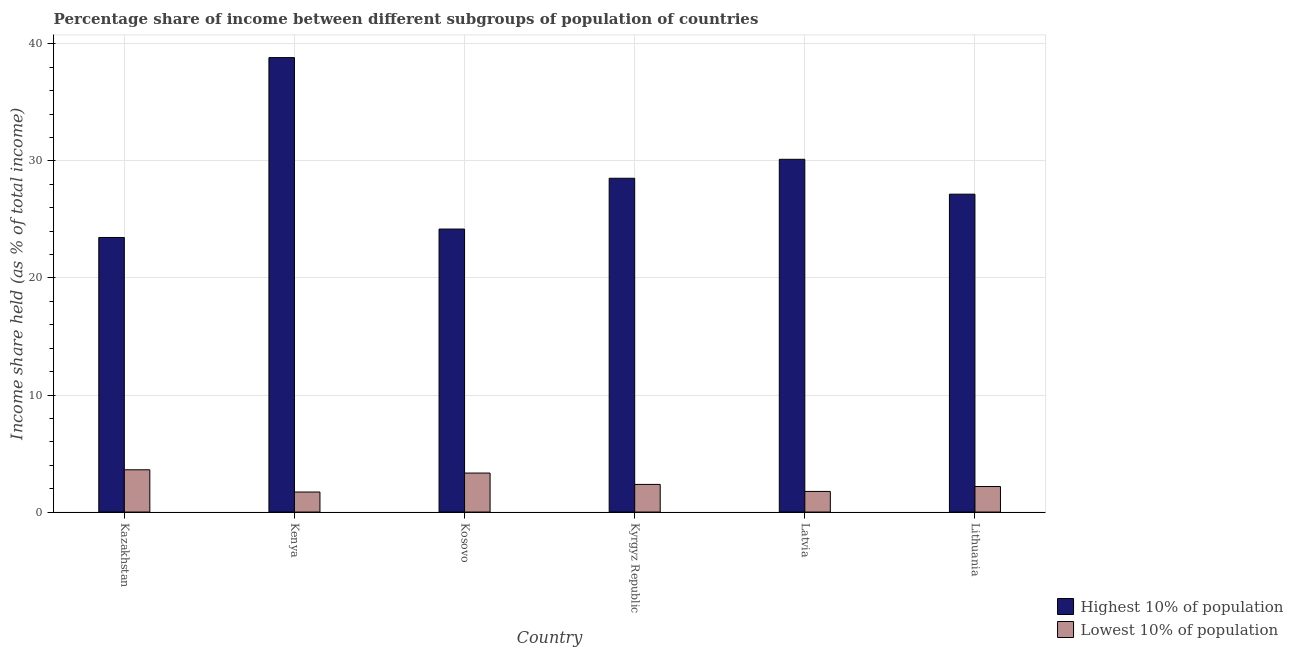How many groups of bars are there?
Provide a succinct answer. 6. Are the number of bars on each tick of the X-axis equal?
Offer a very short reply. Yes. How many bars are there on the 1st tick from the left?
Your answer should be compact. 2. What is the label of the 3rd group of bars from the left?
Provide a short and direct response. Kosovo. In how many cases, is the number of bars for a given country not equal to the number of legend labels?
Ensure brevity in your answer.  0. What is the income share held by lowest 10% of the population in Latvia?
Make the answer very short. 1.76. Across all countries, what is the maximum income share held by highest 10% of the population?
Provide a succinct answer. 38.83. Across all countries, what is the minimum income share held by lowest 10% of the population?
Offer a terse response. 1.71. In which country was the income share held by highest 10% of the population maximum?
Provide a short and direct response. Kenya. In which country was the income share held by highest 10% of the population minimum?
Your answer should be compact. Kazakhstan. What is the total income share held by highest 10% of the population in the graph?
Make the answer very short. 172.29. What is the difference between the income share held by highest 10% of the population in Kenya and that in Lithuania?
Make the answer very short. 11.67. What is the difference between the income share held by lowest 10% of the population in Kazakhstan and the income share held by highest 10% of the population in Latvia?
Your response must be concise. -26.53. What is the average income share held by lowest 10% of the population per country?
Ensure brevity in your answer.  2.49. What is the difference between the income share held by lowest 10% of the population and income share held by highest 10% of the population in Lithuania?
Keep it short and to the point. -24.98. In how many countries, is the income share held by highest 10% of the population greater than 16 %?
Make the answer very short. 6. What is the ratio of the income share held by lowest 10% of the population in Kenya to that in Latvia?
Your answer should be compact. 0.97. Is the income share held by lowest 10% of the population in Kenya less than that in Kosovo?
Give a very brief answer. Yes. Is the difference between the income share held by lowest 10% of the population in Kazakhstan and Kyrgyz Republic greater than the difference between the income share held by highest 10% of the population in Kazakhstan and Kyrgyz Republic?
Make the answer very short. Yes. What is the difference between the highest and the second highest income share held by lowest 10% of the population?
Your answer should be compact. 0.28. What is the difference between the highest and the lowest income share held by highest 10% of the population?
Provide a succinct answer. 15.37. What does the 2nd bar from the left in Kosovo represents?
Make the answer very short. Lowest 10% of population. What does the 1st bar from the right in Kosovo represents?
Keep it short and to the point. Lowest 10% of population. What is the difference between two consecutive major ticks on the Y-axis?
Your answer should be very brief. 10. Are the values on the major ticks of Y-axis written in scientific E-notation?
Your response must be concise. No. What is the title of the graph?
Give a very brief answer. Percentage share of income between different subgroups of population of countries. Does "Depositors" appear as one of the legend labels in the graph?
Your answer should be very brief. No. What is the label or title of the Y-axis?
Ensure brevity in your answer.  Income share held (as % of total income). What is the Income share held (as % of total income) in Highest 10% of population in Kazakhstan?
Ensure brevity in your answer.  23.46. What is the Income share held (as % of total income) of Lowest 10% of population in Kazakhstan?
Make the answer very short. 3.61. What is the Income share held (as % of total income) in Highest 10% of population in Kenya?
Your answer should be compact. 38.83. What is the Income share held (as % of total income) of Lowest 10% of population in Kenya?
Your answer should be compact. 1.71. What is the Income share held (as % of total income) in Highest 10% of population in Kosovo?
Your answer should be compact. 24.18. What is the Income share held (as % of total income) of Lowest 10% of population in Kosovo?
Your answer should be very brief. 3.33. What is the Income share held (as % of total income) of Highest 10% of population in Kyrgyz Republic?
Offer a very short reply. 28.52. What is the Income share held (as % of total income) in Lowest 10% of population in Kyrgyz Republic?
Keep it short and to the point. 2.36. What is the Income share held (as % of total income) in Highest 10% of population in Latvia?
Make the answer very short. 30.14. What is the Income share held (as % of total income) of Lowest 10% of population in Latvia?
Ensure brevity in your answer.  1.76. What is the Income share held (as % of total income) of Highest 10% of population in Lithuania?
Your response must be concise. 27.16. What is the Income share held (as % of total income) in Lowest 10% of population in Lithuania?
Offer a terse response. 2.18. Across all countries, what is the maximum Income share held (as % of total income) in Highest 10% of population?
Your answer should be very brief. 38.83. Across all countries, what is the maximum Income share held (as % of total income) of Lowest 10% of population?
Your answer should be compact. 3.61. Across all countries, what is the minimum Income share held (as % of total income) of Highest 10% of population?
Offer a terse response. 23.46. Across all countries, what is the minimum Income share held (as % of total income) of Lowest 10% of population?
Offer a terse response. 1.71. What is the total Income share held (as % of total income) in Highest 10% of population in the graph?
Keep it short and to the point. 172.29. What is the total Income share held (as % of total income) of Lowest 10% of population in the graph?
Offer a very short reply. 14.95. What is the difference between the Income share held (as % of total income) in Highest 10% of population in Kazakhstan and that in Kenya?
Keep it short and to the point. -15.37. What is the difference between the Income share held (as % of total income) in Highest 10% of population in Kazakhstan and that in Kosovo?
Your answer should be compact. -0.72. What is the difference between the Income share held (as % of total income) of Lowest 10% of population in Kazakhstan and that in Kosovo?
Give a very brief answer. 0.28. What is the difference between the Income share held (as % of total income) of Highest 10% of population in Kazakhstan and that in Kyrgyz Republic?
Give a very brief answer. -5.06. What is the difference between the Income share held (as % of total income) in Highest 10% of population in Kazakhstan and that in Latvia?
Give a very brief answer. -6.68. What is the difference between the Income share held (as % of total income) of Lowest 10% of population in Kazakhstan and that in Latvia?
Give a very brief answer. 1.85. What is the difference between the Income share held (as % of total income) in Highest 10% of population in Kazakhstan and that in Lithuania?
Your answer should be very brief. -3.7. What is the difference between the Income share held (as % of total income) of Lowest 10% of population in Kazakhstan and that in Lithuania?
Offer a very short reply. 1.43. What is the difference between the Income share held (as % of total income) in Highest 10% of population in Kenya and that in Kosovo?
Provide a succinct answer. 14.65. What is the difference between the Income share held (as % of total income) in Lowest 10% of population in Kenya and that in Kosovo?
Provide a succinct answer. -1.62. What is the difference between the Income share held (as % of total income) of Highest 10% of population in Kenya and that in Kyrgyz Republic?
Keep it short and to the point. 10.31. What is the difference between the Income share held (as % of total income) of Lowest 10% of population in Kenya and that in Kyrgyz Republic?
Ensure brevity in your answer.  -0.65. What is the difference between the Income share held (as % of total income) in Highest 10% of population in Kenya and that in Latvia?
Your answer should be compact. 8.69. What is the difference between the Income share held (as % of total income) of Highest 10% of population in Kenya and that in Lithuania?
Your answer should be very brief. 11.67. What is the difference between the Income share held (as % of total income) in Lowest 10% of population in Kenya and that in Lithuania?
Offer a terse response. -0.47. What is the difference between the Income share held (as % of total income) in Highest 10% of population in Kosovo and that in Kyrgyz Republic?
Provide a short and direct response. -4.34. What is the difference between the Income share held (as % of total income) of Highest 10% of population in Kosovo and that in Latvia?
Keep it short and to the point. -5.96. What is the difference between the Income share held (as % of total income) of Lowest 10% of population in Kosovo and that in Latvia?
Provide a short and direct response. 1.57. What is the difference between the Income share held (as % of total income) of Highest 10% of population in Kosovo and that in Lithuania?
Your answer should be very brief. -2.98. What is the difference between the Income share held (as % of total income) in Lowest 10% of population in Kosovo and that in Lithuania?
Ensure brevity in your answer.  1.15. What is the difference between the Income share held (as % of total income) in Highest 10% of population in Kyrgyz Republic and that in Latvia?
Ensure brevity in your answer.  -1.62. What is the difference between the Income share held (as % of total income) in Lowest 10% of population in Kyrgyz Republic and that in Latvia?
Keep it short and to the point. 0.6. What is the difference between the Income share held (as % of total income) of Highest 10% of population in Kyrgyz Republic and that in Lithuania?
Keep it short and to the point. 1.36. What is the difference between the Income share held (as % of total income) in Lowest 10% of population in Kyrgyz Republic and that in Lithuania?
Offer a very short reply. 0.18. What is the difference between the Income share held (as % of total income) of Highest 10% of population in Latvia and that in Lithuania?
Provide a succinct answer. 2.98. What is the difference between the Income share held (as % of total income) of Lowest 10% of population in Latvia and that in Lithuania?
Provide a succinct answer. -0.42. What is the difference between the Income share held (as % of total income) of Highest 10% of population in Kazakhstan and the Income share held (as % of total income) of Lowest 10% of population in Kenya?
Give a very brief answer. 21.75. What is the difference between the Income share held (as % of total income) of Highest 10% of population in Kazakhstan and the Income share held (as % of total income) of Lowest 10% of population in Kosovo?
Your answer should be very brief. 20.13. What is the difference between the Income share held (as % of total income) in Highest 10% of population in Kazakhstan and the Income share held (as % of total income) in Lowest 10% of population in Kyrgyz Republic?
Your response must be concise. 21.1. What is the difference between the Income share held (as % of total income) of Highest 10% of population in Kazakhstan and the Income share held (as % of total income) of Lowest 10% of population in Latvia?
Your answer should be very brief. 21.7. What is the difference between the Income share held (as % of total income) in Highest 10% of population in Kazakhstan and the Income share held (as % of total income) in Lowest 10% of population in Lithuania?
Your response must be concise. 21.28. What is the difference between the Income share held (as % of total income) in Highest 10% of population in Kenya and the Income share held (as % of total income) in Lowest 10% of population in Kosovo?
Keep it short and to the point. 35.5. What is the difference between the Income share held (as % of total income) in Highest 10% of population in Kenya and the Income share held (as % of total income) in Lowest 10% of population in Kyrgyz Republic?
Provide a succinct answer. 36.47. What is the difference between the Income share held (as % of total income) in Highest 10% of population in Kenya and the Income share held (as % of total income) in Lowest 10% of population in Latvia?
Ensure brevity in your answer.  37.07. What is the difference between the Income share held (as % of total income) in Highest 10% of population in Kenya and the Income share held (as % of total income) in Lowest 10% of population in Lithuania?
Keep it short and to the point. 36.65. What is the difference between the Income share held (as % of total income) of Highest 10% of population in Kosovo and the Income share held (as % of total income) of Lowest 10% of population in Kyrgyz Republic?
Make the answer very short. 21.82. What is the difference between the Income share held (as % of total income) of Highest 10% of population in Kosovo and the Income share held (as % of total income) of Lowest 10% of population in Latvia?
Ensure brevity in your answer.  22.42. What is the difference between the Income share held (as % of total income) of Highest 10% of population in Kosovo and the Income share held (as % of total income) of Lowest 10% of population in Lithuania?
Provide a short and direct response. 22. What is the difference between the Income share held (as % of total income) in Highest 10% of population in Kyrgyz Republic and the Income share held (as % of total income) in Lowest 10% of population in Latvia?
Make the answer very short. 26.76. What is the difference between the Income share held (as % of total income) of Highest 10% of population in Kyrgyz Republic and the Income share held (as % of total income) of Lowest 10% of population in Lithuania?
Offer a terse response. 26.34. What is the difference between the Income share held (as % of total income) in Highest 10% of population in Latvia and the Income share held (as % of total income) in Lowest 10% of population in Lithuania?
Give a very brief answer. 27.96. What is the average Income share held (as % of total income) in Highest 10% of population per country?
Offer a very short reply. 28.71. What is the average Income share held (as % of total income) of Lowest 10% of population per country?
Ensure brevity in your answer.  2.49. What is the difference between the Income share held (as % of total income) of Highest 10% of population and Income share held (as % of total income) of Lowest 10% of population in Kazakhstan?
Make the answer very short. 19.85. What is the difference between the Income share held (as % of total income) of Highest 10% of population and Income share held (as % of total income) of Lowest 10% of population in Kenya?
Provide a succinct answer. 37.12. What is the difference between the Income share held (as % of total income) of Highest 10% of population and Income share held (as % of total income) of Lowest 10% of population in Kosovo?
Ensure brevity in your answer.  20.85. What is the difference between the Income share held (as % of total income) of Highest 10% of population and Income share held (as % of total income) of Lowest 10% of population in Kyrgyz Republic?
Offer a very short reply. 26.16. What is the difference between the Income share held (as % of total income) of Highest 10% of population and Income share held (as % of total income) of Lowest 10% of population in Latvia?
Ensure brevity in your answer.  28.38. What is the difference between the Income share held (as % of total income) in Highest 10% of population and Income share held (as % of total income) in Lowest 10% of population in Lithuania?
Your response must be concise. 24.98. What is the ratio of the Income share held (as % of total income) of Highest 10% of population in Kazakhstan to that in Kenya?
Offer a very short reply. 0.6. What is the ratio of the Income share held (as % of total income) of Lowest 10% of population in Kazakhstan to that in Kenya?
Give a very brief answer. 2.11. What is the ratio of the Income share held (as % of total income) of Highest 10% of population in Kazakhstan to that in Kosovo?
Ensure brevity in your answer.  0.97. What is the ratio of the Income share held (as % of total income) of Lowest 10% of population in Kazakhstan to that in Kosovo?
Make the answer very short. 1.08. What is the ratio of the Income share held (as % of total income) of Highest 10% of population in Kazakhstan to that in Kyrgyz Republic?
Ensure brevity in your answer.  0.82. What is the ratio of the Income share held (as % of total income) in Lowest 10% of population in Kazakhstan to that in Kyrgyz Republic?
Make the answer very short. 1.53. What is the ratio of the Income share held (as % of total income) in Highest 10% of population in Kazakhstan to that in Latvia?
Keep it short and to the point. 0.78. What is the ratio of the Income share held (as % of total income) of Lowest 10% of population in Kazakhstan to that in Latvia?
Your answer should be very brief. 2.05. What is the ratio of the Income share held (as % of total income) of Highest 10% of population in Kazakhstan to that in Lithuania?
Ensure brevity in your answer.  0.86. What is the ratio of the Income share held (as % of total income) in Lowest 10% of population in Kazakhstan to that in Lithuania?
Offer a terse response. 1.66. What is the ratio of the Income share held (as % of total income) of Highest 10% of population in Kenya to that in Kosovo?
Your answer should be compact. 1.61. What is the ratio of the Income share held (as % of total income) of Lowest 10% of population in Kenya to that in Kosovo?
Offer a very short reply. 0.51. What is the ratio of the Income share held (as % of total income) in Highest 10% of population in Kenya to that in Kyrgyz Republic?
Give a very brief answer. 1.36. What is the ratio of the Income share held (as % of total income) of Lowest 10% of population in Kenya to that in Kyrgyz Republic?
Make the answer very short. 0.72. What is the ratio of the Income share held (as % of total income) of Highest 10% of population in Kenya to that in Latvia?
Ensure brevity in your answer.  1.29. What is the ratio of the Income share held (as % of total income) of Lowest 10% of population in Kenya to that in Latvia?
Provide a succinct answer. 0.97. What is the ratio of the Income share held (as % of total income) in Highest 10% of population in Kenya to that in Lithuania?
Make the answer very short. 1.43. What is the ratio of the Income share held (as % of total income) of Lowest 10% of population in Kenya to that in Lithuania?
Keep it short and to the point. 0.78. What is the ratio of the Income share held (as % of total income) in Highest 10% of population in Kosovo to that in Kyrgyz Republic?
Offer a very short reply. 0.85. What is the ratio of the Income share held (as % of total income) of Lowest 10% of population in Kosovo to that in Kyrgyz Republic?
Ensure brevity in your answer.  1.41. What is the ratio of the Income share held (as % of total income) of Highest 10% of population in Kosovo to that in Latvia?
Provide a succinct answer. 0.8. What is the ratio of the Income share held (as % of total income) of Lowest 10% of population in Kosovo to that in Latvia?
Offer a very short reply. 1.89. What is the ratio of the Income share held (as % of total income) in Highest 10% of population in Kosovo to that in Lithuania?
Make the answer very short. 0.89. What is the ratio of the Income share held (as % of total income) of Lowest 10% of population in Kosovo to that in Lithuania?
Keep it short and to the point. 1.53. What is the ratio of the Income share held (as % of total income) in Highest 10% of population in Kyrgyz Republic to that in Latvia?
Keep it short and to the point. 0.95. What is the ratio of the Income share held (as % of total income) of Lowest 10% of population in Kyrgyz Republic to that in Latvia?
Your answer should be compact. 1.34. What is the ratio of the Income share held (as % of total income) of Highest 10% of population in Kyrgyz Republic to that in Lithuania?
Make the answer very short. 1.05. What is the ratio of the Income share held (as % of total income) of Lowest 10% of population in Kyrgyz Republic to that in Lithuania?
Ensure brevity in your answer.  1.08. What is the ratio of the Income share held (as % of total income) in Highest 10% of population in Latvia to that in Lithuania?
Provide a short and direct response. 1.11. What is the ratio of the Income share held (as % of total income) in Lowest 10% of population in Latvia to that in Lithuania?
Ensure brevity in your answer.  0.81. What is the difference between the highest and the second highest Income share held (as % of total income) in Highest 10% of population?
Ensure brevity in your answer.  8.69. What is the difference between the highest and the second highest Income share held (as % of total income) in Lowest 10% of population?
Provide a short and direct response. 0.28. What is the difference between the highest and the lowest Income share held (as % of total income) of Highest 10% of population?
Your answer should be very brief. 15.37. 